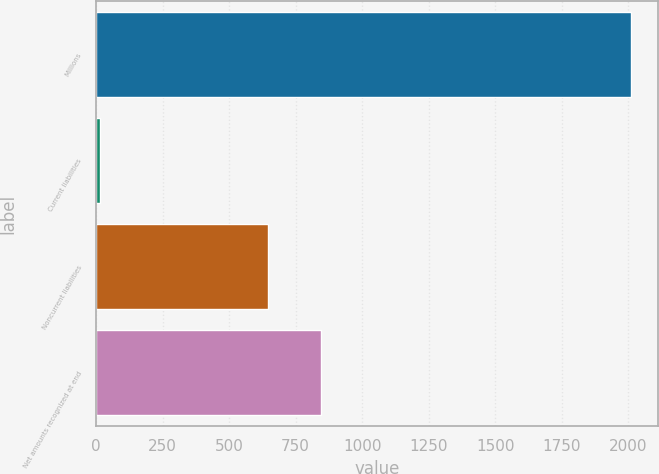<chart> <loc_0><loc_0><loc_500><loc_500><bar_chart><fcel>Millions<fcel>Current liabilities<fcel>Noncurrent liabilities<fcel>Net amounts recognized at end<nl><fcel>2011<fcel>15<fcel>645<fcel>844.6<nl></chart> 